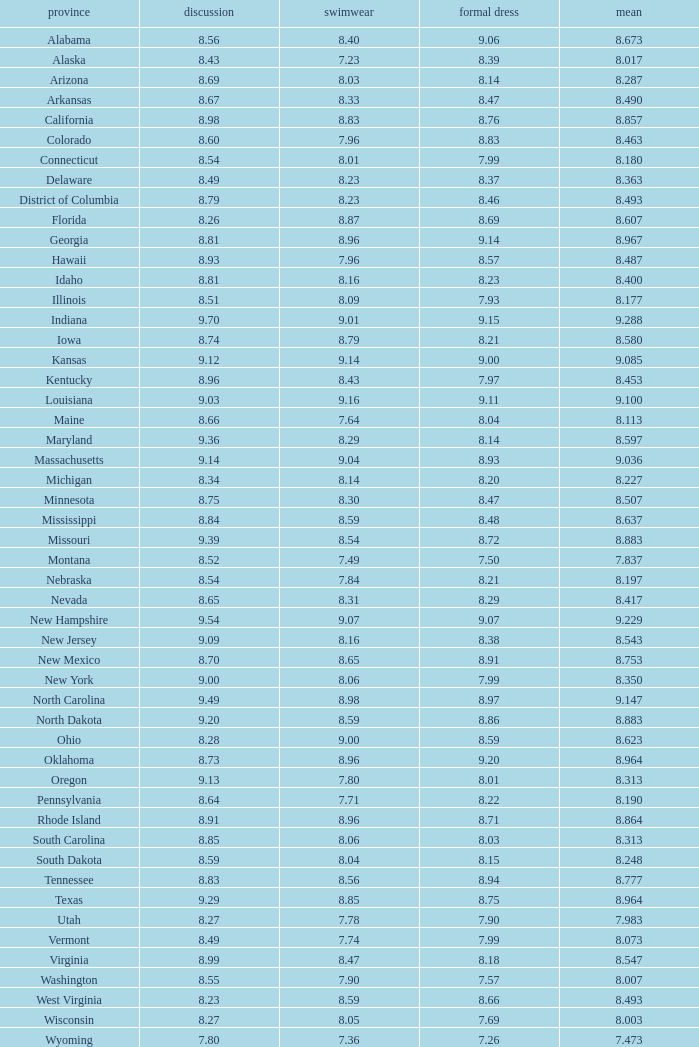Tell me the sum of interview for evening gown more than 8.37 and average of 8.363 None. 